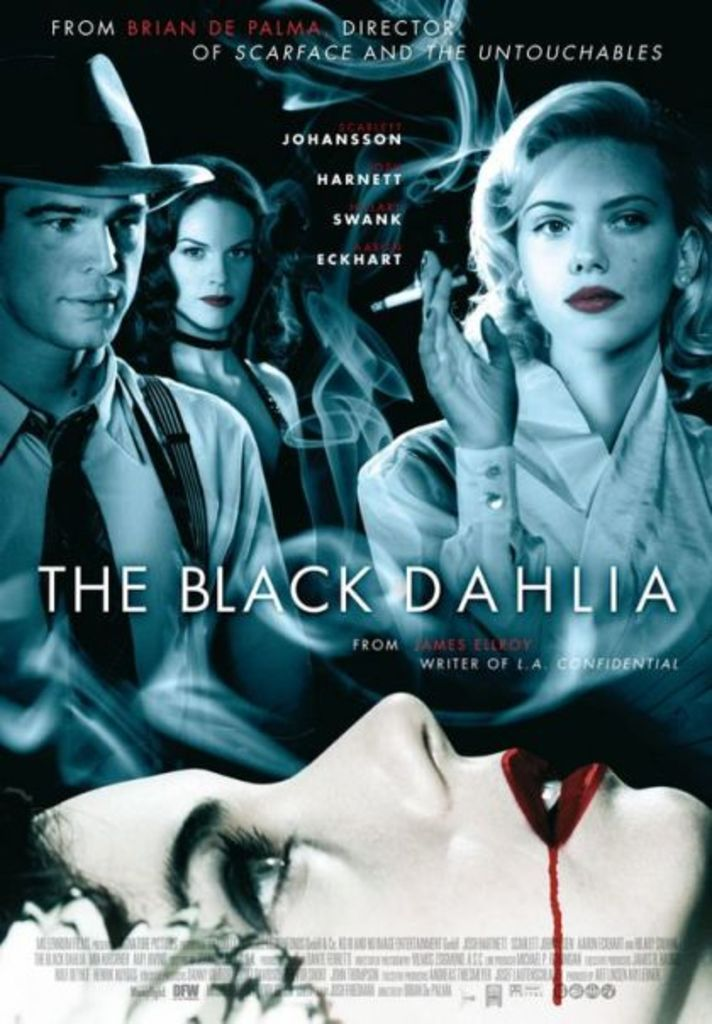Who directed 'The Black Dahlia,' and what other notable films has he directed? The film 'The Black Dahlia' was directed by Brian De Palma, who is also known for directing other acclaimed movies such as 'Scarface' and 'The Untouchables'. 